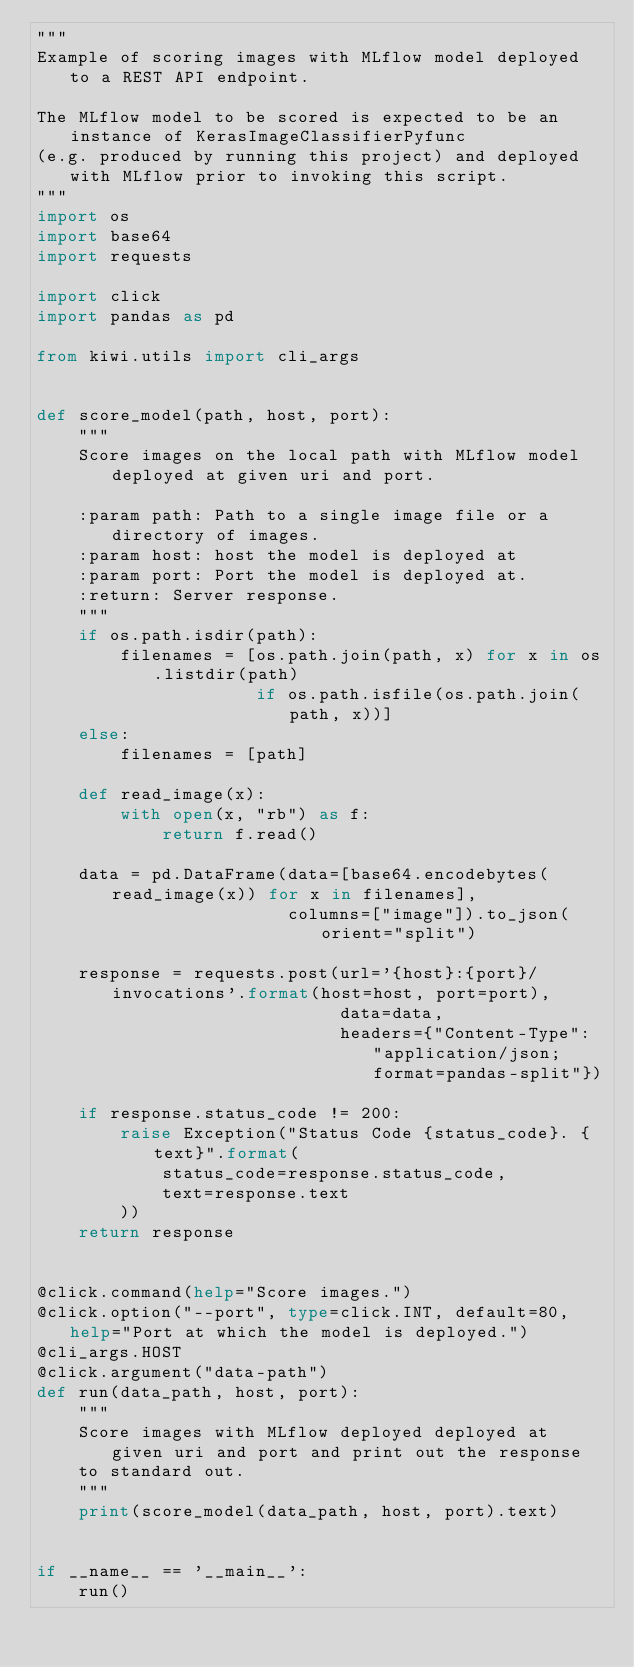Convert code to text. <code><loc_0><loc_0><loc_500><loc_500><_Python_>"""
Example of scoring images with MLflow model deployed to a REST API endpoint.

The MLflow model to be scored is expected to be an instance of KerasImageClassifierPyfunc
(e.g. produced by running this project) and deployed with MLflow prior to invoking this script.
"""
import os
import base64
import requests

import click
import pandas as pd

from kiwi.utils import cli_args


def score_model(path, host, port):
    """
    Score images on the local path with MLflow model deployed at given uri and port.

    :param path: Path to a single image file or a directory of images.
    :param host: host the model is deployed at
    :param port: Port the model is deployed at.
    :return: Server response.
    """
    if os.path.isdir(path):
        filenames = [os.path.join(path, x) for x in os.listdir(path)
                     if os.path.isfile(os.path.join(path, x))]
    else:
        filenames = [path]

    def read_image(x):
        with open(x, "rb") as f:
            return f.read()

    data = pd.DataFrame(data=[base64.encodebytes(read_image(x)) for x in filenames],
                        columns=["image"]).to_json(orient="split")

    response = requests.post(url='{host}:{port}/invocations'.format(host=host, port=port),
                             data=data,
                             headers={"Content-Type": "application/json; format=pandas-split"})

    if response.status_code != 200:
        raise Exception("Status Code {status_code}. {text}".format(
            status_code=response.status_code,
            text=response.text
        ))
    return response


@click.command(help="Score images.")
@click.option("--port", type=click.INT, default=80, help="Port at which the model is deployed.")
@cli_args.HOST
@click.argument("data-path")
def run(data_path, host, port):
    """
    Score images with MLflow deployed deployed at given uri and port and print out the response
    to standard out.
    """
    print(score_model(data_path, host, port).text)


if __name__ == '__main__':
    run()
</code> 